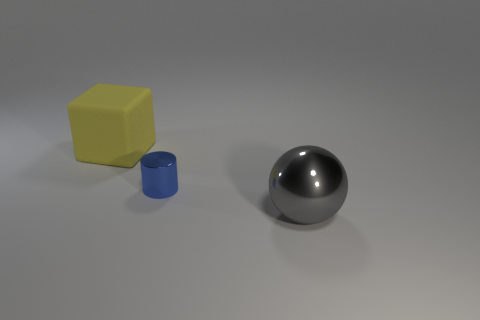Is there any other thing that is the same size as the blue metallic thing?
Your answer should be very brief. No. How many big purple things have the same material as the blue cylinder?
Ensure brevity in your answer.  0. What material is the cylinder?
Keep it short and to the point. Metal. What is the shape of the large thing in front of the big object left of the blue object?
Ensure brevity in your answer.  Sphere. There is a big object right of the small thing; what is its shape?
Offer a terse response. Sphere. How many large shiny balls are the same color as the tiny thing?
Give a very brief answer. 0. The tiny thing is what color?
Provide a short and direct response. Blue. How many small blue metallic things are behind the big thing on the left side of the tiny cylinder?
Your response must be concise. 0. There is a yellow object; is its size the same as the metallic object to the left of the gray metallic object?
Offer a terse response. No. Do the sphere and the blue metal cylinder have the same size?
Ensure brevity in your answer.  No. 